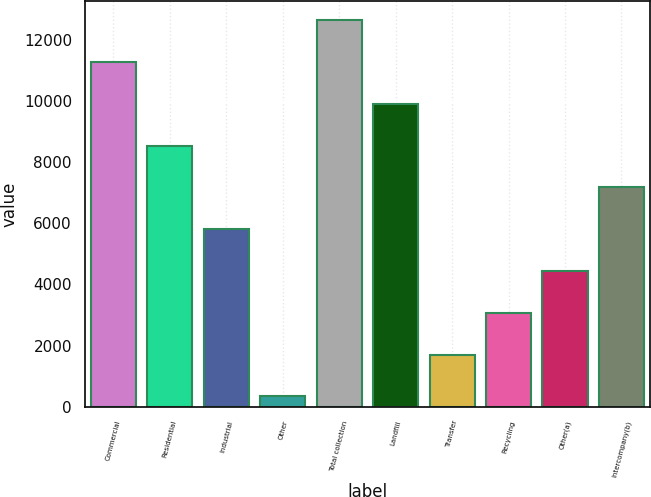Convert chart. <chart><loc_0><loc_0><loc_500><loc_500><bar_chart><fcel>Commercial<fcel>Residential<fcel>Industrial<fcel>Other<fcel>Total collection<fcel>Landfill<fcel>Transfer<fcel>Recycling<fcel>Other(a)<fcel>Intercompany(b)<nl><fcel>11264.8<fcel>8533.6<fcel>5802.4<fcel>340<fcel>12630.4<fcel>9899.2<fcel>1705.6<fcel>3071.2<fcel>4436.8<fcel>7168<nl></chart> 